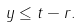Convert formula to latex. <formula><loc_0><loc_0><loc_500><loc_500>y \leq t - r .</formula> 